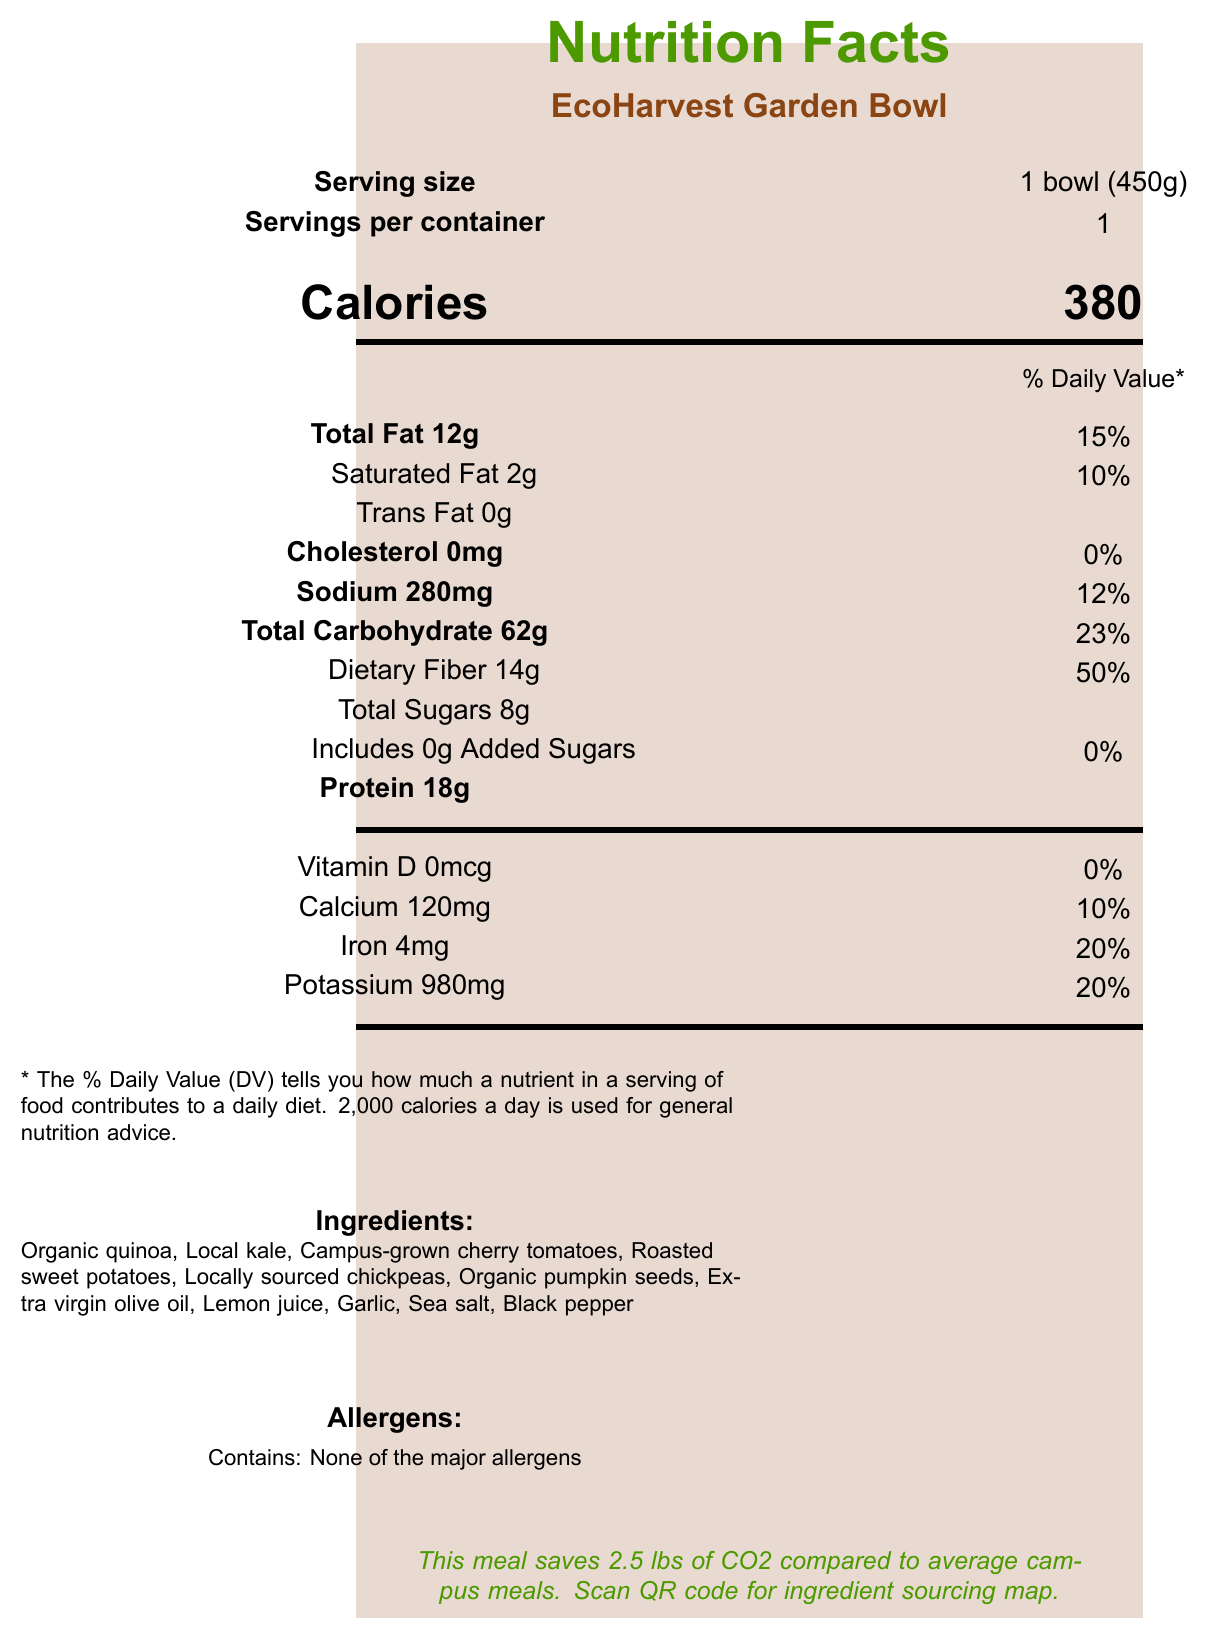what is the serving size of the EcoHarvest Garden Bowl? The serving size is specified right after the product name and serving information section.
Answer: 1 bowl (450g) how many calories are in one serving of this meal? The calorie information is displayed prominently in the "Calories" section.
Answer: 380 what percentage of the daily value of dietary fiber does one serving provide? The dietary fiber section shows that 14g is 50% of the daily value.
Answer: 50% how much protein is in the EcoHarvest Garden Bowl? The protein content is listed in the nutrient information section as 18g.
Answer: 18g are there any major allergens present in the EcoHarvest Garden Bowl? The allergen information section specifies "Contains: None of the major allergens."
Answer: No what are some sustainability features of this meal? A. Uses organic ingredients B. Compostable packaging C. Sustainable sourcing D. All of the above The sustainability features include 100% locally sourced ingredients, seasonal vegetables from the campus garden, compostable packaging, and zero food waste initiatives.
Answer: D. All of the above what is the highest percentage of daily value provided by any nutrient? A. Total Fat B. Saturated Fat C. Dietary Fiber D. Sodium Dietary fiber provides 50% of the daily value, which is the highest percentage mentioned.
Answer: C. Dietary Fiber is the EcoHarvest Garden Bowl high in sodium? With 280mg of sodium which is 12% of the daily value, it is not considered high in sodium.
Answer: No does this meal contain any added sugars? The nutrient information shows 0g added sugars, contributing 0% of the daily value.
Answer: No describe the main idea of this document The document combines nutritional data with information about the meal's ingredients, environmental benefits, and educational components related to sustainability and interdisciplinary education.
Answer: The document provides the nutritional information, ingredient list, allergen information, sustainability features, and interdisciplinary aspects of the EcoHarvest Garden Bowl, a sustainable and healthy meal option for the campus dining. how much calcium is in one serving, and what percentage of the daily value does it represent? The calcium content is listed in the nutrient section showing 120mg which represents 10% of the daily value.
Answer: 120mg, 10% how much potassium is in the EcoHarvest Garden Bowl? The potassium content is listed in the nutrient information section as 980mg.
Answer: 980mg does the meal include added sugars? A. Yes B. No C. Not specified The document clearly states that added sugars are 0g, with a daily value of 0%.
Answer: B. No where do the ingredients in the EcoHarvest Garden Bowl come from? The sustainability features indicate that 100% of the ingredients are locally sourced within 50 miles, and some come from the campus garden.
Answer: Within 50 miles and some from the campus garden how much iron does the meal provide per serving? The iron content is listed in the nutrient information section as 4mg.
Answer: 4mg what is the main fat component percentage in the EcoHarvest Garden Bowl? The total fat section indicates 12g as 15% of the daily value.
Answer: Total Fat 12g, 15% how can students learn more about the sourcing of the ingredients? The eco-education section mentions the QR code linking to the ingredient sourcing map.
Answer: By scanning the QR code on the document what amount of sodium is there per serving? The sodium content is specified in the nutrient information section as 280mg.
Answer: 280mg what is the main purpose of the EcoHarvest Garden Bowl? The document combines nutritional information with aspects of sustainability, local sourcing, and interdisciplinary educational value to provide a comprehensive overview of the meal's purpose.
Answer: To offer a nutritious, sustainable, and educational meal that promotes environmental awareness and interdisciplinary learning. which department might use this document to discuss local food systems? The interdisciplinary aspects indicate Environmental Science as one of the departments focusing on sustainable agriculture and local ecosystems.
Answer: Environmental Science does the EcoHarvest Garden Bowl contain any animal products? The document does not explicitly state whether any of the ingredients are animal products, so we cannot confirm this based on the information provided.
Answer: Cannot be determined 